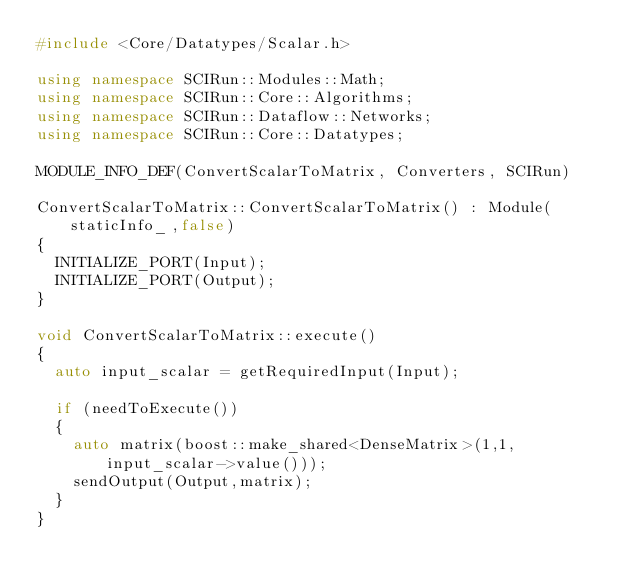Convert code to text. <code><loc_0><loc_0><loc_500><loc_500><_C++_>#include <Core/Datatypes/Scalar.h>

using namespace SCIRun::Modules::Math;
using namespace SCIRun::Core::Algorithms;
using namespace SCIRun::Dataflow::Networks;
using namespace SCIRun::Core::Datatypes;

MODULE_INFO_DEF(ConvertScalarToMatrix, Converters, SCIRun)

ConvertScalarToMatrix::ConvertScalarToMatrix() : Module(staticInfo_,false)
{
  INITIALIZE_PORT(Input);
  INITIALIZE_PORT(Output);
}

void ConvertScalarToMatrix::execute()
{
  auto input_scalar = getRequiredInput(Input);

  if (needToExecute())
  {
    auto matrix(boost::make_shared<DenseMatrix>(1,1,input_scalar->value()));
    sendOutput(Output,matrix);
  }
}
</code> 